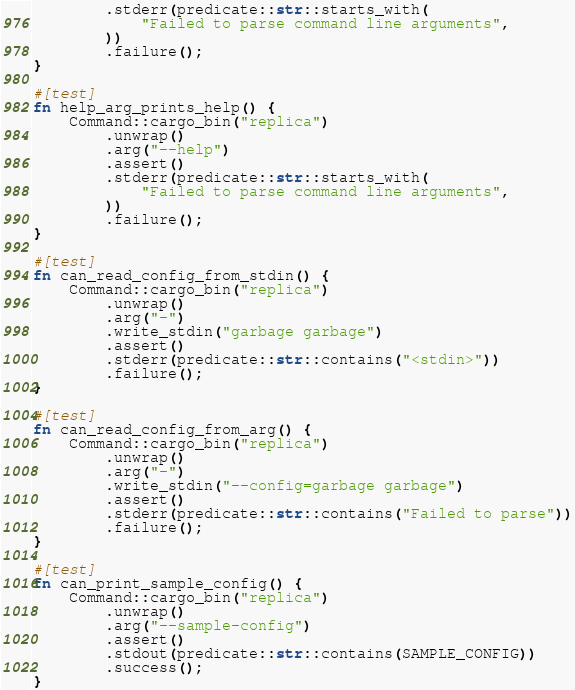Convert code to text. <code><loc_0><loc_0><loc_500><loc_500><_Rust_>        .stderr(predicate::str::starts_with(
            "Failed to parse command line arguments",
        ))
        .failure();
}

#[test]
fn help_arg_prints_help() {
    Command::cargo_bin("replica")
        .unwrap()
        .arg("--help")
        .assert()
        .stderr(predicate::str::starts_with(
            "Failed to parse command line arguments",
        ))
        .failure();
}

#[test]
fn can_read_config_from_stdin() {
    Command::cargo_bin("replica")
        .unwrap()
        .arg("-")
        .write_stdin("garbage garbage")
        .assert()
        .stderr(predicate::str::contains("<stdin>"))
        .failure();
}

#[test]
fn can_read_config_from_arg() {
    Command::cargo_bin("replica")
        .unwrap()
        .arg("-")
        .write_stdin("--config=garbage garbage")
        .assert()
        .stderr(predicate::str::contains("Failed to parse"))
        .failure();
}

#[test]
fn can_print_sample_config() {
    Command::cargo_bin("replica")
        .unwrap()
        .arg("--sample-config")
        .assert()
        .stdout(predicate::str::contains(SAMPLE_CONFIG))
        .success();
}
</code> 